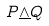<formula> <loc_0><loc_0><loc_500><loc_500>P \underline { \wedge } Q</formula> 